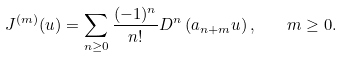Convert formula to latex. <formula><loc_0><loc_0><loc_500><loc_500>J ^ { ( m ) } ( u ) = \sum _ { n \geq 0 } \frac { ( - 1 ) ^ { n } } { n ! } D ^ { n } \left ( a _ { n + m } u \right ) , \quad m \geq 0 .</formula> 